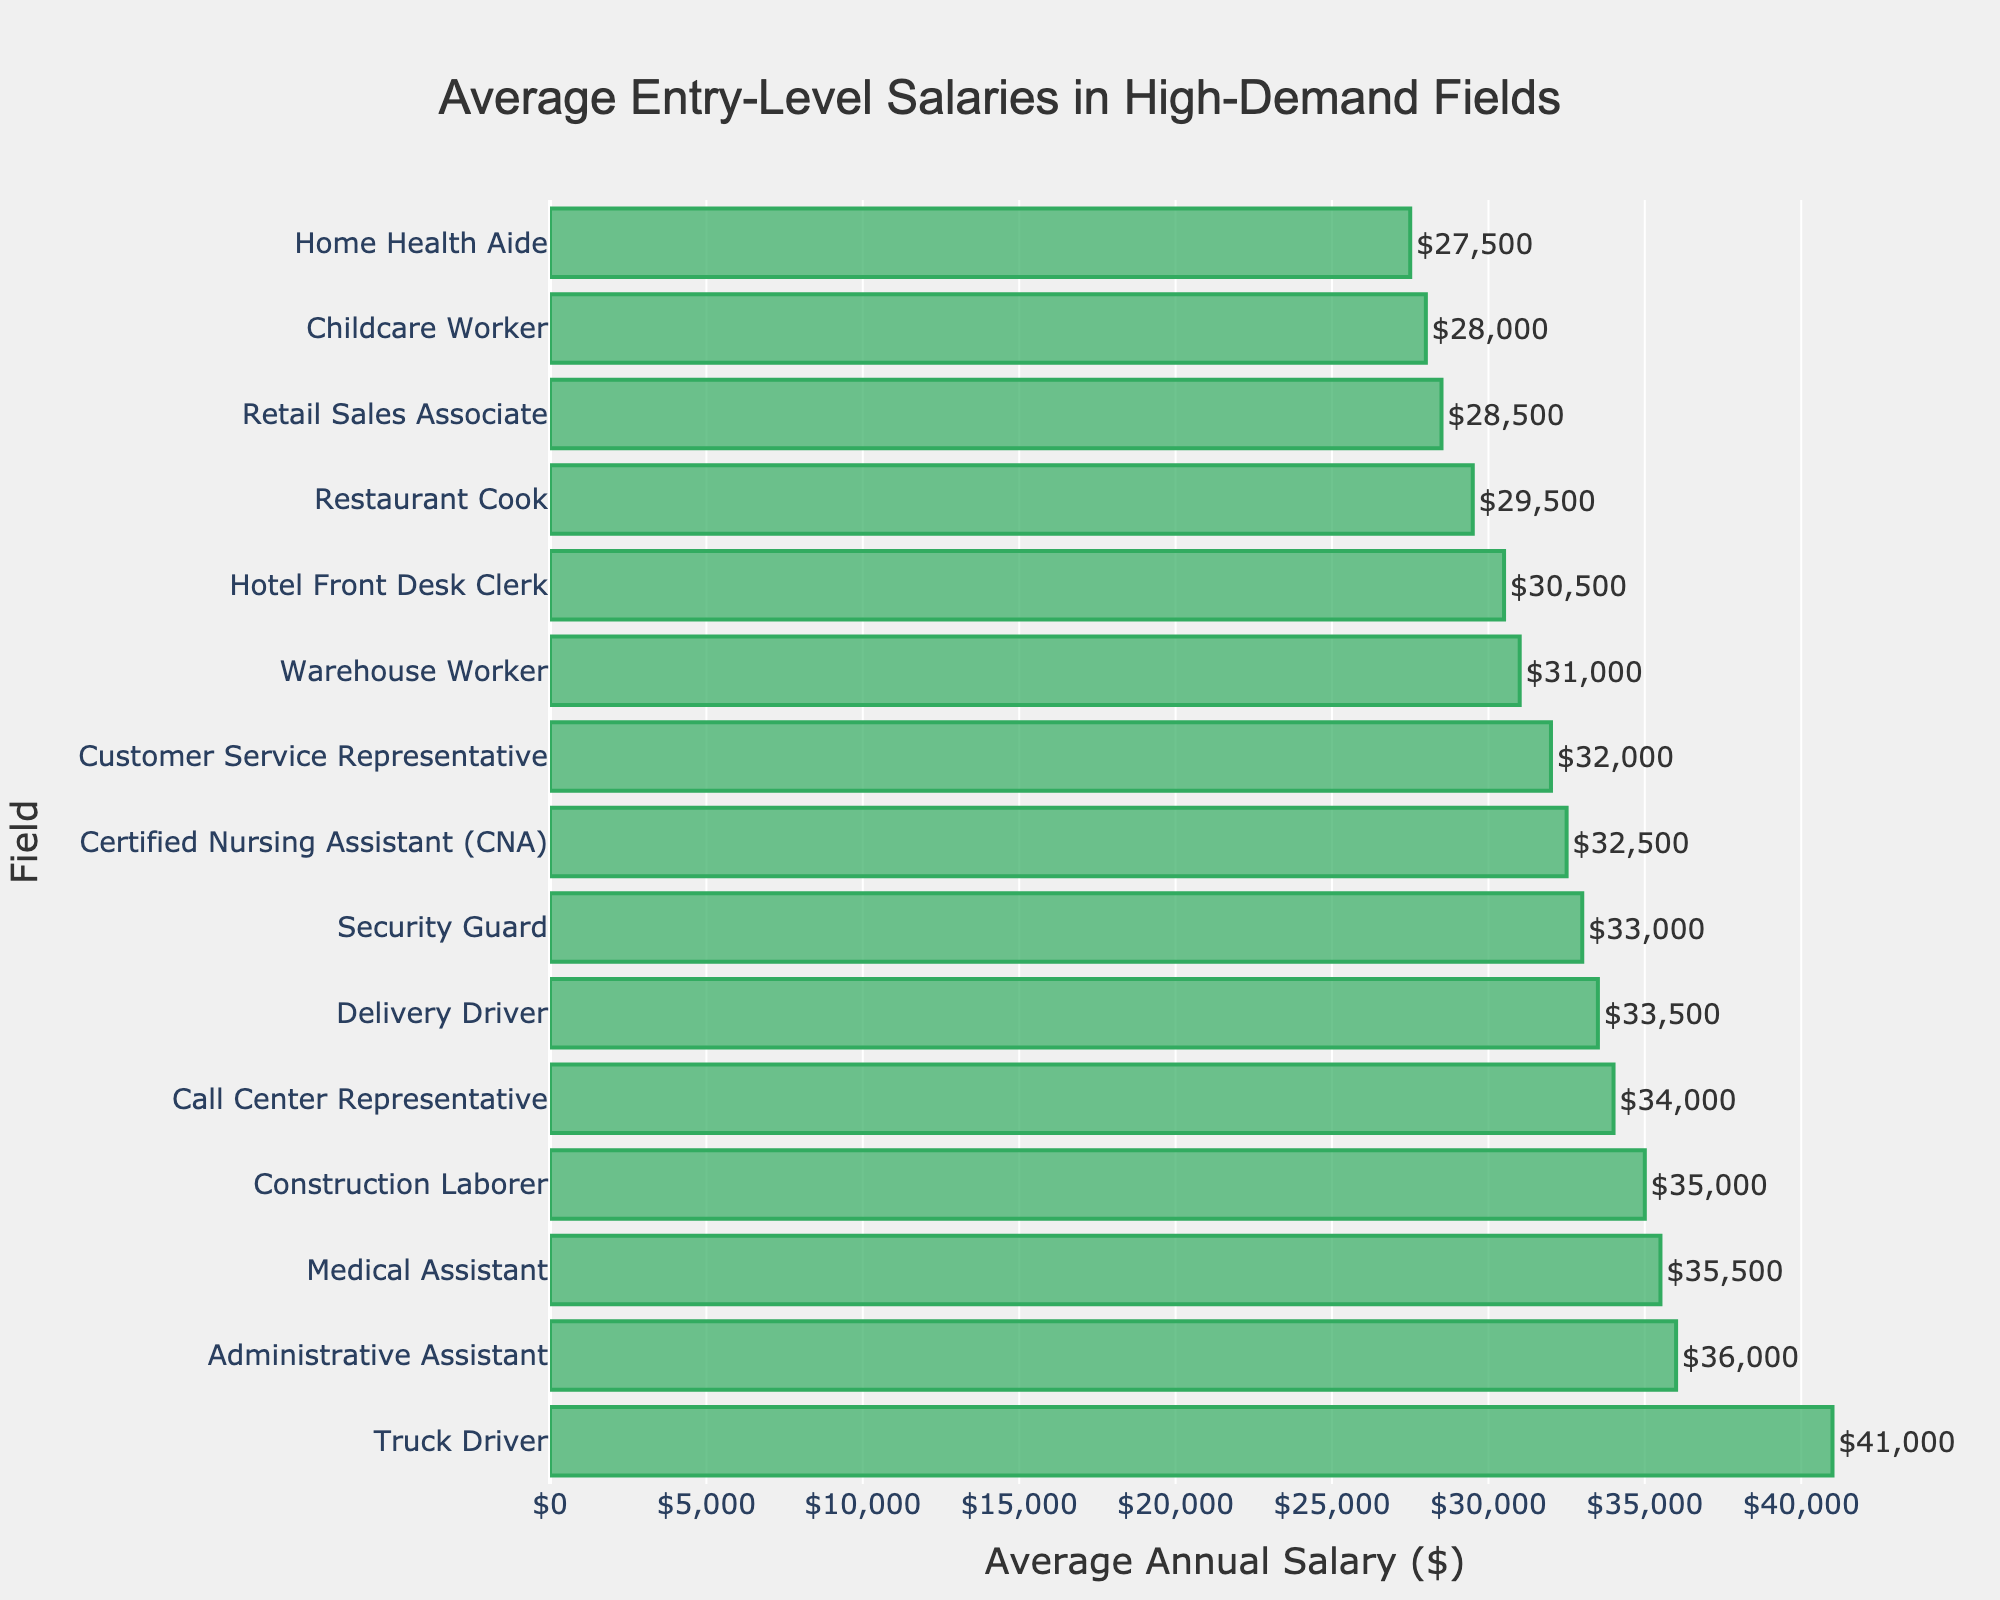Which field has the highest average annual salary? The field with the highest average annual salary can be found by looking for the bar that extends the farthest to the right. In the chart, this is the bar for the Truck Driver position.
Answer: Truck Driver What is the difference in the average annual salary between a Customer Service Representative and a Retail Sales Associate? To find the difference, subtract the average salary of a Retail Sales Associate from that of a Customer Service Representative: $32,000 - $28,500.
Answer: $3,500 Which fields have average annual salaries greater than $35,000? To determine which fields have salaries greater than $35,000, look for bars that extend beyond the $35,000 mark on the x-axis. The fields are Medical Assistant, Administrative Assistant, and Truck Driver.
Answer: Medical Assistant, Administrative Assistant, Truck Driver What is the combined average annual salary of a Medical Assistant, a Security Guard, and a Delivery Driver? Sum the average salaries of these three positions: $35,500 (Medical Assistant) + $33,000 (Security Guard) + $33,500 (Delivery Driver).
Answer: $102,000 How many fields have an average annual salary below $30,000? Count the number of bars that fall below the $30,000 mark on the x-axis. These fields are Retail Sales Associate, Home Health Aide, Restaurant Cook, and Childcare Worker.
Answer: 4 What is the average annual salary of the lowest-paid position? The lowest-paid position has the bar that extends the least to the right. This is the Home Health Aide with an average annual salary of $27,500.
Answer: $27,500 Compare the average annual salary of a Construction Laborer to that of a Certified Nursing Assistant (CNA). Which one is higher and by how much? The average salary of a Construction Laborer is $35,000, while that of a CNA is $32,500. Subtract to find the difference: $35,000 - $32,500.
Answer: Construction Laborer is higher by $2,500 What is the total average annual salary for positions with salaries above $30,000 but below $35,000? Identify those positions: Customer Service Representative ($32,000), Security Guard ($33,000), Call Center Representative ($34,000), Construction Laborer ($35,000), and Delivery Driver ($33,500). Sum these salaries: $32,000 + $33,000 + $34,000 + $35,000 + $33,500.
Answer: $167,500 Which position has an average annual salary closest to $30,000? Look for the bar that is nearest to the $30,000 mark. The Hotel Front Desk Clerk has an average annual salary of $30,500.
Answer: Hotel Front Desk Clerk 